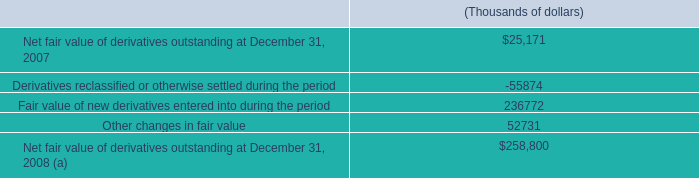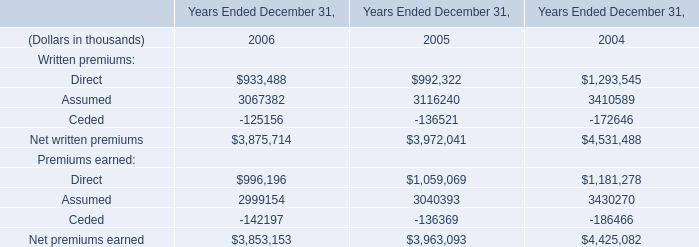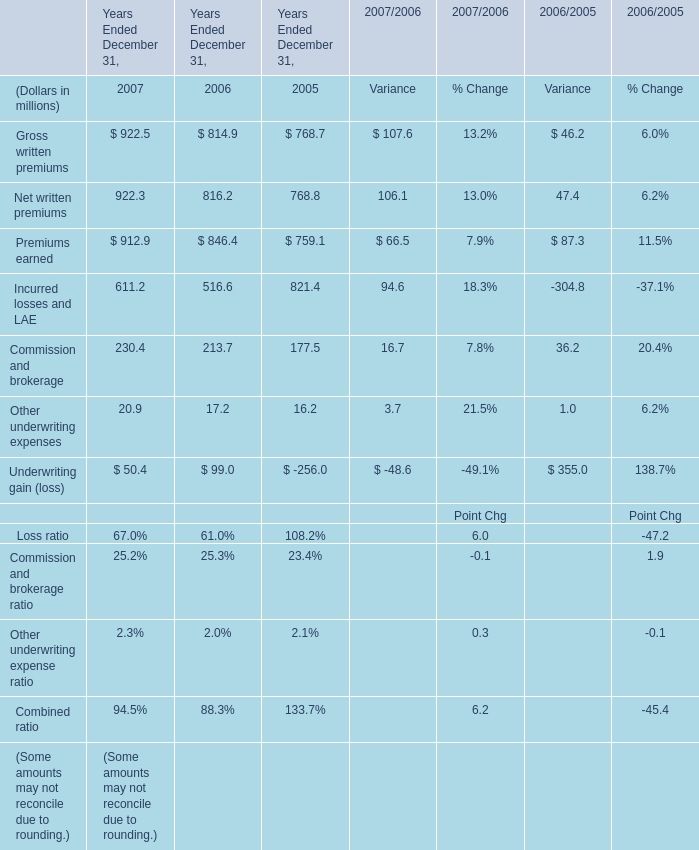What will Net written premiums be like in 2007 Ended December 31 if it develops with the same increasing rate as in 2006 Ended December 31? (in million) 
Computations: (816.2 * (1 + ((816.2 - 768.8) / 768.8)))
Answer: 866.52242. 